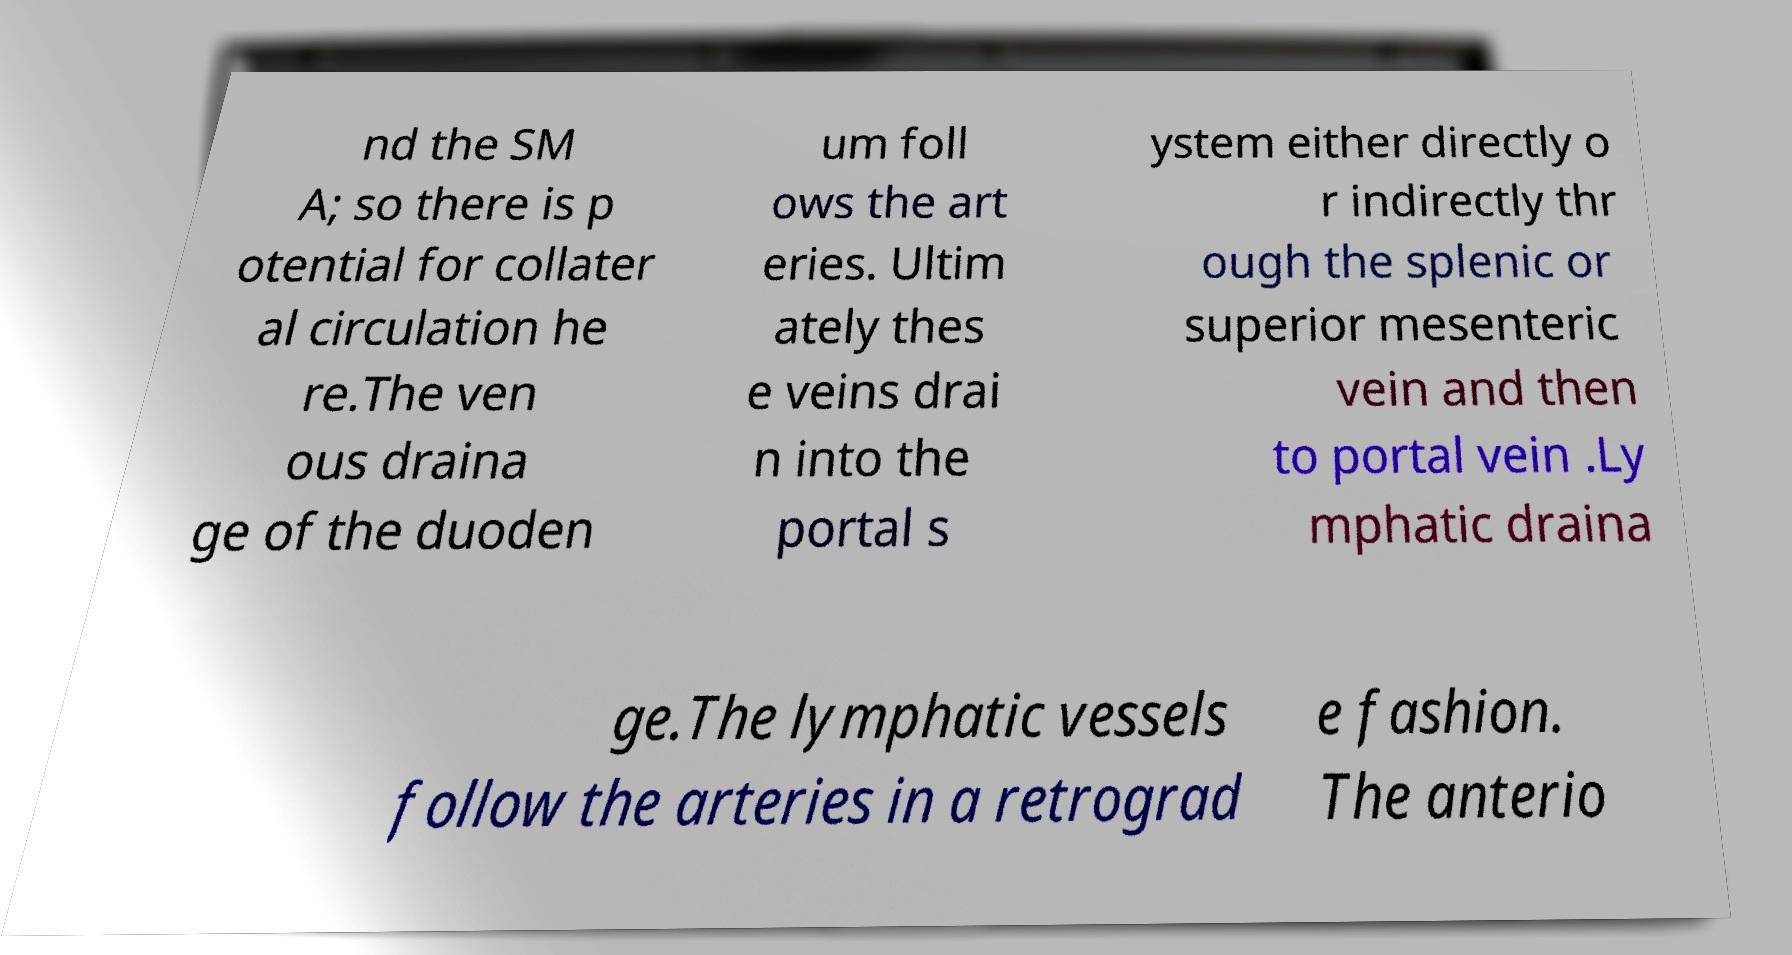Can you read and provide the text displayed in the image?This photo seems to have some interesting text. Can you extract and type it out for me? nd the SM A; so there is p otential for collater al circulation he re.The ven ous draina ge of the duoden um foll ows the art eries. Ultim ately thes e veins drai n into the portal s ystem either directly o r indirectly thr ough the splenic or superior mesenteric vein and then to portal vein .Ly mphatic draina ge.The lymphatic vessels follow the arteries in a retrograd e fashion. The anterio 